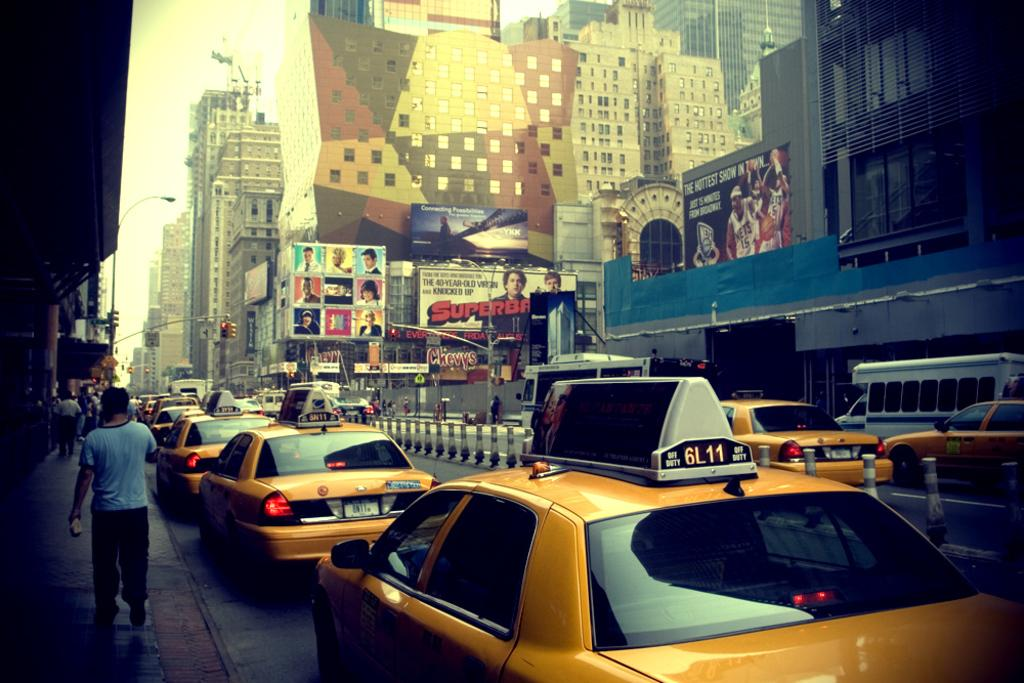<image>
Render a clear and concise summary of the photo. A street scene with a number of yellow taxis, one of which reads 6L11 